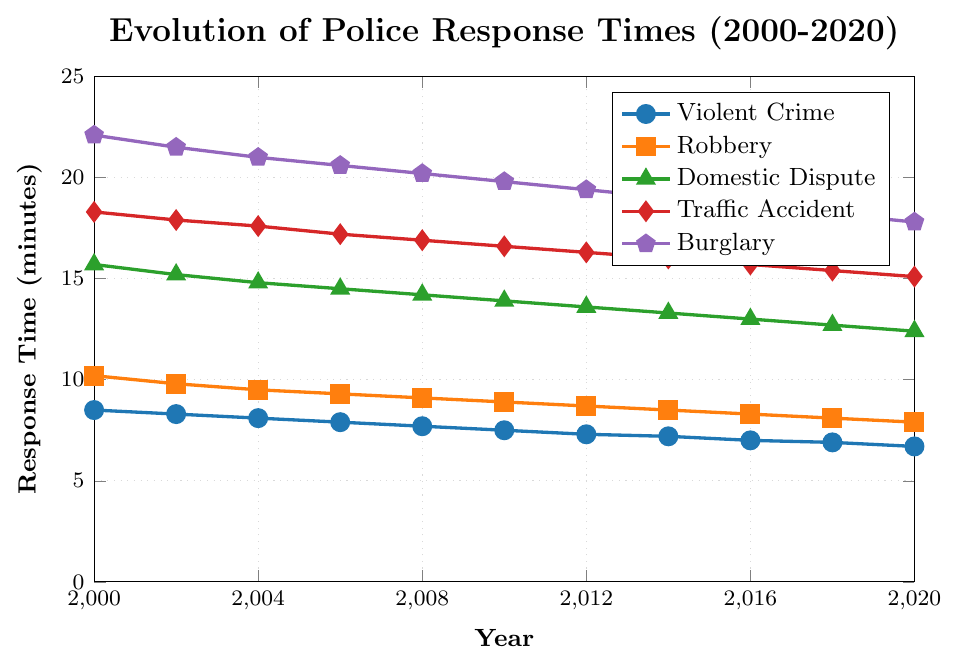What is the overall trend in police response times for Violent Crimes from 2000 to 2020? The response times for Violent Crimes have decreased continuously over the period. In 2000, the response time was 8.5 minutes and it dropped to 6.7 minutes by 2020.
Answer: Decreasing Which type of emergency call had the highest response time in 2000? Comparing the numbers visually, Domestic Dispute had the highest response time at 22.1 minutes in 2000.
Answer: Domestic Dispute Between Robbery and Traffic Accident, which emergency call had a lower response time in 2010? In 2010, the response time for Robbery was 8.9 minutes and for Traffic Accident it was 16.6 minutes. Therefore, Robbery had the lower response time.
Answer: Robbery What is the difference in response times for Burglary between 2000 and 2020? Subtract the response time for Burglary in 2020 from the response time in 2000: 22.1 - 17.8 = 4.3 minutes.
Answer: 4.3 minutes Which type of emergency call showed the most significant decrease in response time from 2000 to 2020? By examining the differences visually across all the emergency types, Burglary decreased from 22.1 minutes in 2000 to 17.8 minutes in 2020, highlighting a largest drop.
Answer: Burglary How does the response time for Domestic Dispute in 2000 compare to that in 2020? The response time for Domestic Dispute was 15.7 minutes in 2000 and dropped to 12.4 minutes in 2020, a decrease of 3.3 minutes.
Answer: Decreased by 3.3 minutes What is the average response time for Robbery over the years 2000, 2004, and 2008? To find the average: (10.2 + 9.5 + 9.1) / 3 = 9.6 minutes.
Answer: 9.6 minutes Which emergency type had the smallest reduction in response time from 2000 to 2020? Comparing the differences, Violent Crime decreased from 8.5 minutes in 2000 to 6.7 minutes in 2020, showing the smallest reduction of 1.8 minutes.
Answer: Violent Crime Are there any years where the response time for Robbery is equal to the response time for Violent Crime? No, the visual inspection shows no overlap between the response times for Robbery and Violent Crime at any year.
Answer: No 